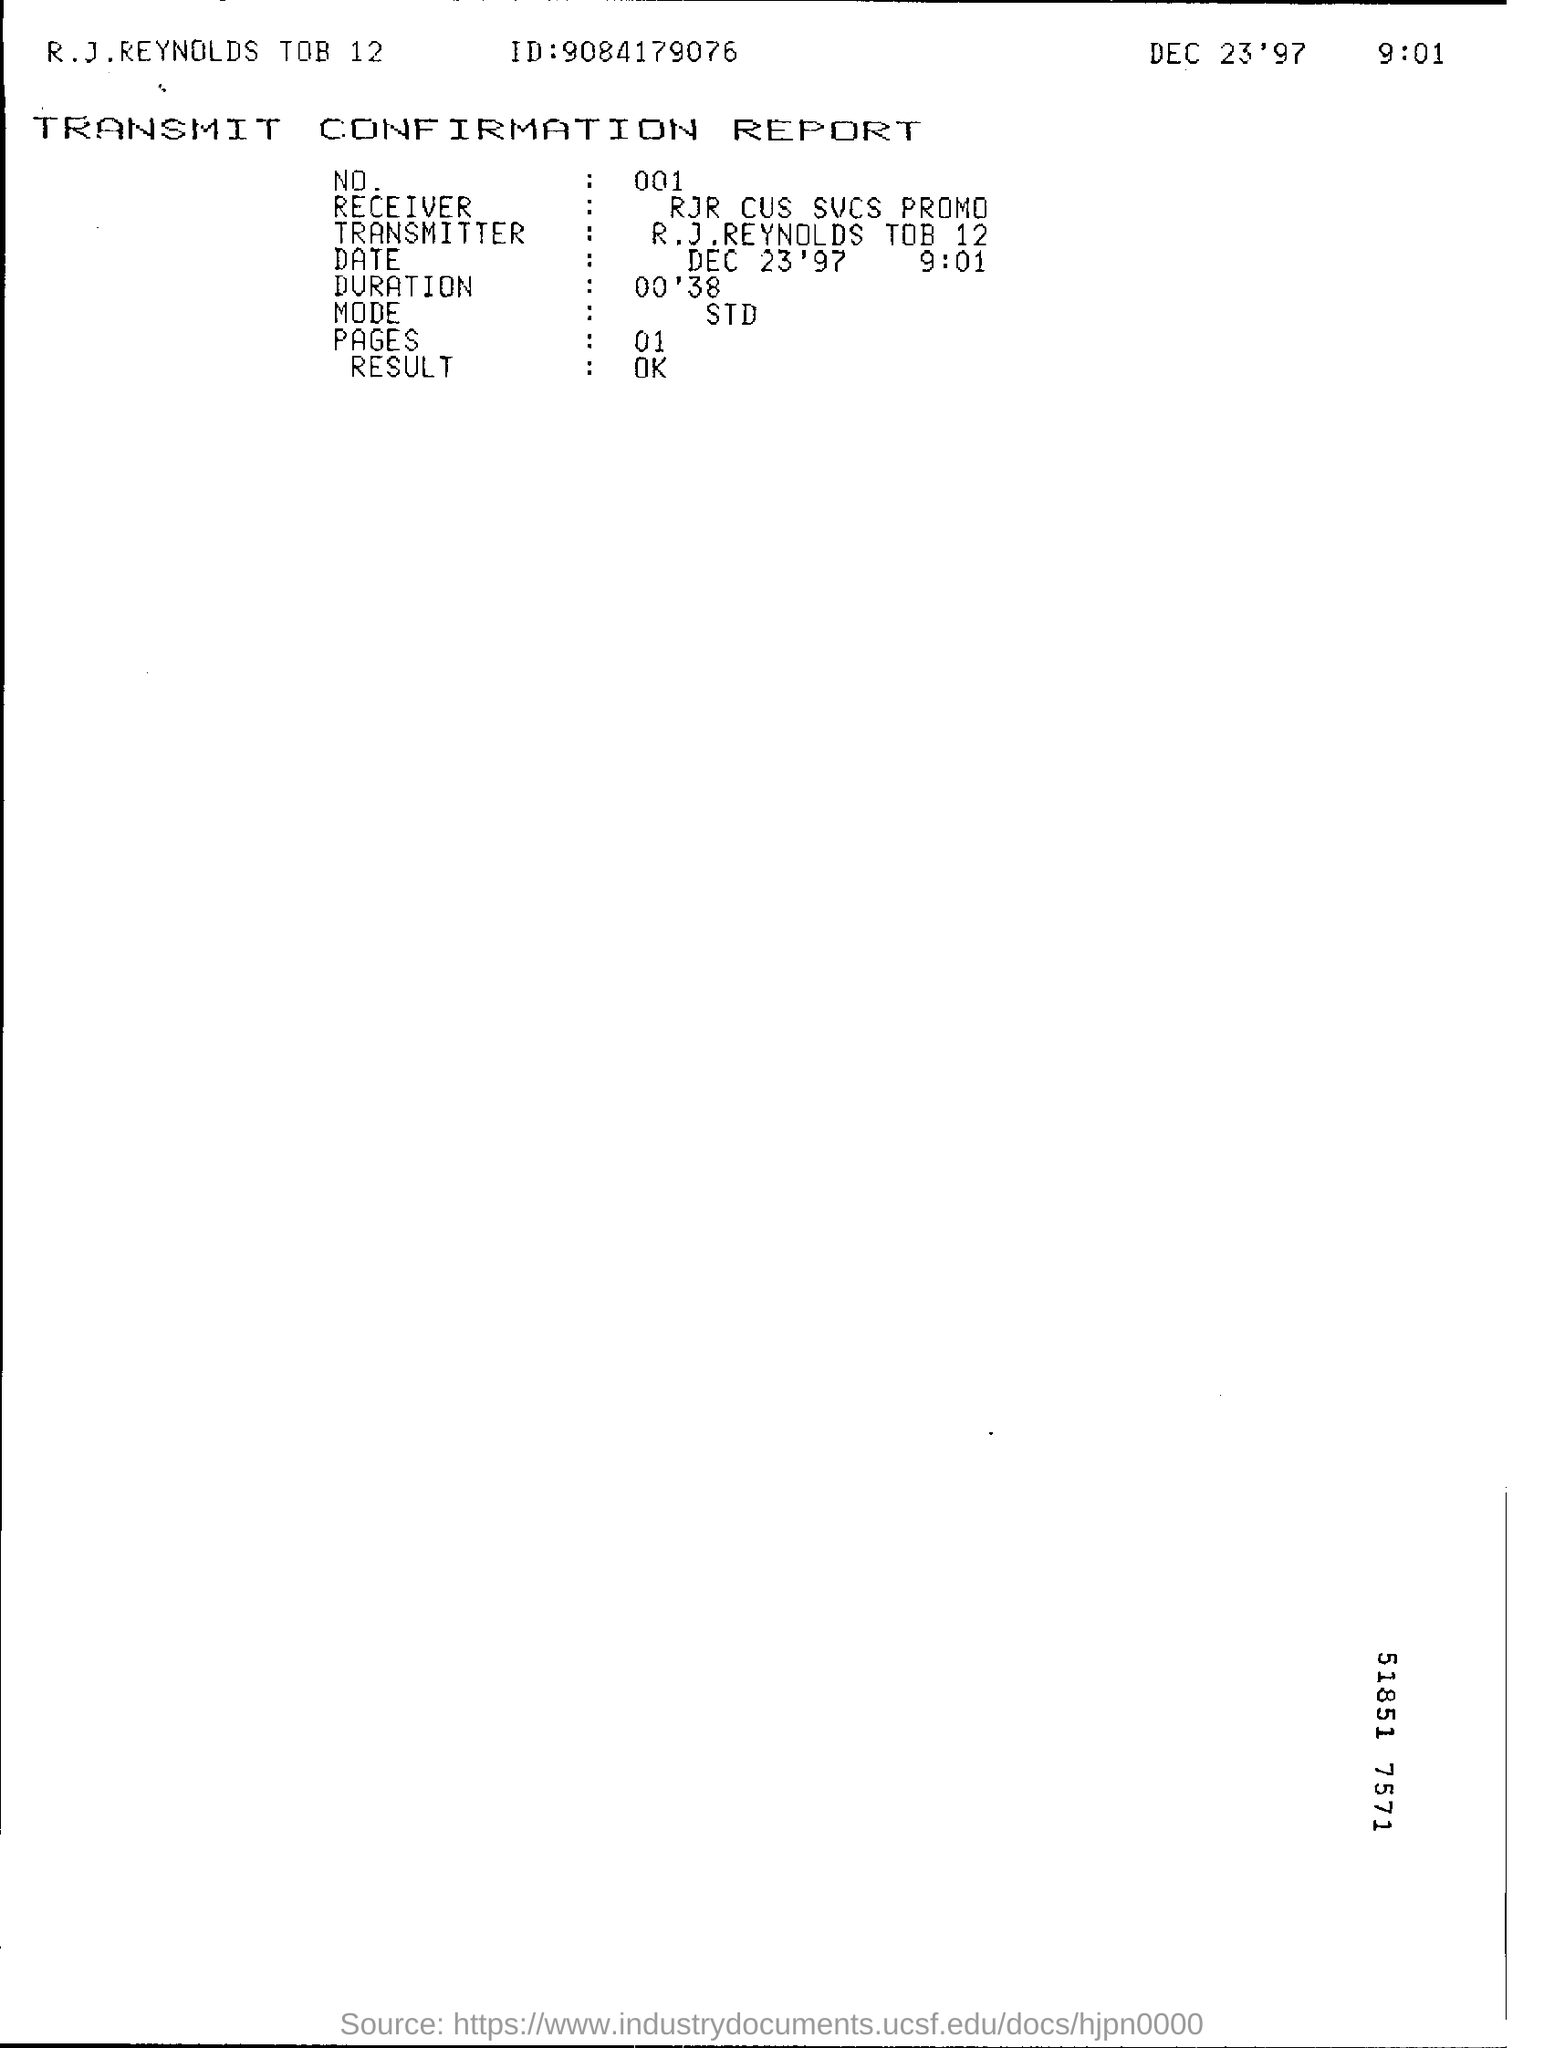What is the mode of transmit?
Keep it short and to the point. STD. What is the name of the receiver?
Provide a succinct answer. Rjr cus svcs promo. What is the result of the report?
Provide a short and direct response. OK. 